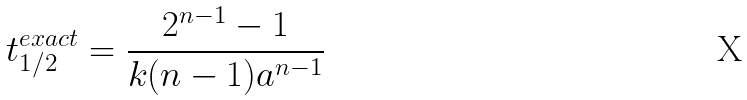Convert formula to latex. <formula><loc_0><loc_0><loc_500><loc_500>t _ { 1 / 2 } ^ { e x a c t } = \frac { 2 ^ { n - 1 } - 1 } { k ( n - 1 ) a ^ { n - 1 } }</formula> 